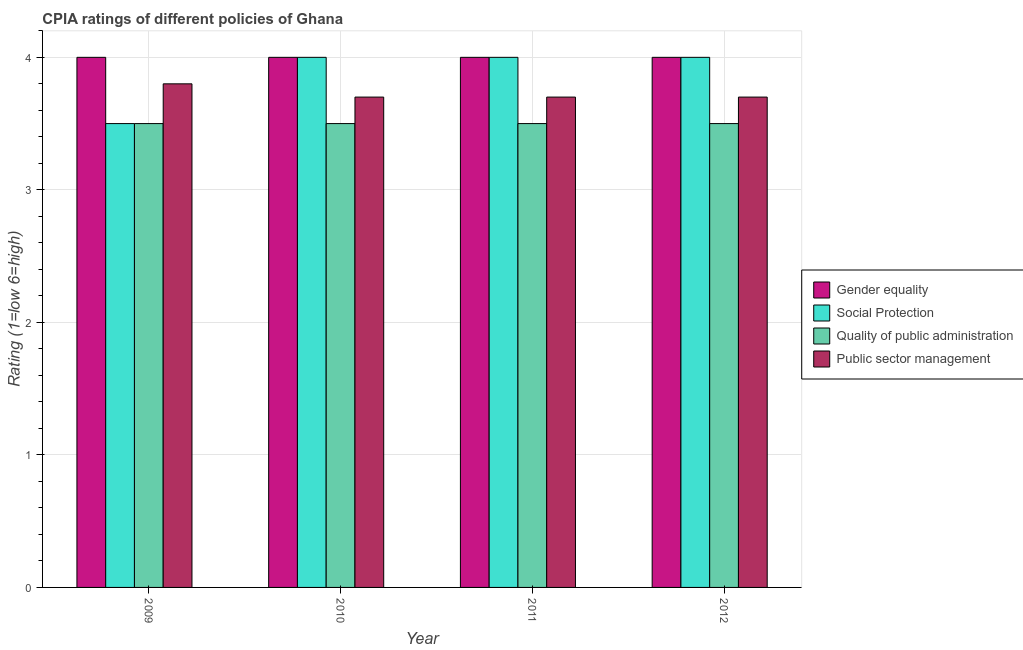How many different coloured bars are there?
Offer a very short reply. 4. How many groups of bars are there?
Give a very brief answer. 4. Are the number of bars on each tick of the X-axis equal?
Offer a very short reply. Yes. How many bars are there on the 2nd tick from the left?
Offer a very short reply. 4. What is the label of the 1st group of bars from the left?
Provide a short and direct response. 2009. Across all years, what is the maximum cpia rating of quality of public administration?
Offer a very short reply. 3.5. Across all years, what is the minimum cpia rating of quality of public administration?
Offer a terse response. 3.5. In which year was the cpia rating of gender equality maximum?
Your response must be concise. 2009. In which year was the cpia rating of gender equality minimum?
Offer a very short reply. 2009. What is the total cpia rating of public sector management in the graph?
Ensure brevity in your answer.  14.9. What is the difference between the cpia rating of gender equality in 2012 and the cpia rating of social protection in 2009?
Make the answer very short. 0. What is the average cpia rating of social protection per year?
Offer a terse response. 3.88. What is the ratio of the cpia rating of public sector management in 2010 to that in 2012?
Your response must be concise. 1. Is the cpia rating of public sector management in 2009 less than that in 2012?
Your response must be concise. No. What is the difference between the highest and the second highest cpia rating of social protection?
Provide a succinct answer. 0. Is the sum of the cpia rating of quality of public administration in 2011 and 2012 greater than the maximum cpia rating of gender equality across all years?
Give a very brief answer. Yes. What does the 3rd bar from the left in 2009 represents?
Keep it short and to the point. Quality of public administration. What does the 4th bar from the right in 2010 represents?
Ensure brevity in your answer.  Gender equality. What is the difference between two consecutive major ticks on the Y-axis?
Offer a very short reply. 1. Does the graph contain any zero values?
Provide a short and direct response. No. Does the graph contain grids?
Offer a very short reply. Yes. Where does the legend appear in the graph?
Your response must be concise. Center right. How many legend labels are there?
Ensure brevity in your answer.  4. How are the legend labels stacked?
Provide a short and direct response. Vertical. What is the title of the graph?
Offer a very short reply. CPIA ratings of different policies of Ghana. What is the Rating (1=low 6=high) in Social Protection in 2009?
Make the answer very short. 3.5. What is the Rating (1=low 6=high) of Quality of public administration in 2009?
Give a very brief answer. 3.5. What is the Rating (1=low 6=high) in Social Protection in 2010?
Your answer should be compact. 4. What is the Rating (1=low 6=high) of Gender equality in 2011?
Provide a succinct answer. 4. What is the Rating (1=low 6=high) of Social Protection in 2011?
Offer a terse response. 4. What is the Rating (1=low 6=high) of Gender equality in 2012?
Your answer should be compact. 4. What is the Rating (1=low 6=high) in Social Protection in 2012?
Offer a terse response. 4. What is the Rating (1=low 6=high) of Quality of public administration in 2012?
Provide a short and direct response. 3.5. Across all years, what is the maximum Rating (1=low 6=high) of Gender equality?
Keep it short and to the point. 4. Across all years, what is the maximum Rating (1=low 6=high) in Social Protection?
Ensure brevity in your answer.  4. Across all years, what is the minimum Rating (1=low 6=high) of Social Protection?
Provide a short and direct response. 3.5. Across all years, what is the minimum Rating (1=low 6=high) in Public sector management?
Keep it short and to the point. 3.7. What is the total Rating (1=low 6=high) of Gender equality in the graph?
Give a very brief answer. 16. What is the total Rating (1=low 6=high) in Social Protection in the graph?
Your answer should be compact. 15.5. What is the total Rating (1=low 6=high) in Quality of public administration in the graph?
Offer a very short reply. 14. What is the difference between the Rating (1=low 6=high) in Social Protection in 2009 and that in 2010?
Your answer should be compact. -0.5. What is the difference between the Rating (1=low 6=high) in Quality of public administration in 2009 and that in 2010?
Keep it short and to the point. 0. What is the difference between the Rating (1=low 6=high) of Gender equality in 2009 and that in 2011?
Your answer should be compact. 0. What is the difference between the Rating (1=low 6=high) in Quality of public administration in 2009 and that in 2011?
Make the answer very short. 0. What is the difference between the Rating (1=low 6=high) of Public sector management in 2009 and that in 2011?
Provide a succinct answer. 0.1. What is the difference between the Rating (1=low 6=high) in Gender equality in 2009 and that in 2012?
Give a very brief answer. 0. What is the difference between the Rating (1=low 6=high) in Public sector management in 2009 and that in 2012?
Your response must be concise. 0.1. What is the difference between the Rating (1=low 6=high) of Quality of public administration in 2010 and that in 2011?
Your answer should be compact. 0. What is the difference between the Rating (1=low 6=high) in Public sector management in 2010 and that in 2011?
Give a very brief answer. 0. What is the difference between the Rating (1=low 6=high) in Gender equality in 2010 and that in 2012?
Ensure brevity in your answer.  0. What is the difference between the Rating (1=low 6=high) of Social Protection in 2010 and that in 2012?
Your response must be concise. 0. What is the difference between the Rating (1=low 6=high) in Public sector management in 2010 and that in 2012?
Offer a very short reply. 0. What is the difference between the Rating (1=low 6=high) in Social Protection in 2011 and that in 2012?
Your answer should be very brief. 0. What is the difference between the Rating (1=low 6=high) in Quality of public administration in 2011 and that in 2012?
Keep it short and to the point. 0. What is the difference between the Rating (1=low 6=high) in Gender equality in 2009 and the Rating (1=low 6=high) in Social Protection in 2010?
Offer a very short reply. 0. What is the difference between the Rating (1=low 6=high) in Gender equality in 2009 and the Rating (1=low 6=high) in Quality of public administration in 2010?
Offer a terse response. 0.5. What is the difference between the Rating (1=low 6=high) of Social Protection in 2009 and the Rating (1=low 6=high) of Quality of public administration in 2010?
Offer a terse response. 0. What is the difference between the Rating (1=low 6=high) in Social Protection in 2009 and the Rating (1=low 6=high) in Public sector management in 2010?
Give a very brief answer. -0.2. What is the difference between the Rating (1=low 6=high) of Quality of public administration in 2009 and the Rating (1=low 6=high) of Public sector management in 2010?
Give a very brief answer. -0.2. What is the difference between the Rating (1=low 6=high) in Gender equality in 2009 and the Rating (1=low 6=high) in Public sector management in 2011?
Provide a short and direct response. 0.3. What is the difference between the Rating (1=low 6=high) in Social Protection in 2009 and the Rating (1=low 6=high) in Quality of public administration in 2011?
Your response must be concise. 0. What is the difference between the Rating (1=low 6=high) in Gender equality in 2009 and the Rating (1=low 6=high) in Quality of public administration in 2012?
Offer a terse response. 0.5. What is the difference between the Rating (1=low 6=high) in Gender equality in 2010 and the Rating (1=low 6=high) in Social Protection in 2011?
Keep it short and to the point. 0. What is the difference between the Rating (1=low 6=high) in Gender equality in 2010 and the Rating (1=low 6=high) in Quality of public administration in 2011?
Give a very brief answer. 0.5. What is the difference between the Rating (1=low 6=high) of Gender equality in 2010 and the Rating (1=low 6=high) of Public sector management in 2011?
Make the answer very short. 0.3. What is the difference between the Rating (1=low 6=high) in Social Protection in 2010 and the Rating (1=low 6=high) in Quality of public administration in 2011?
Keep it short and to the point. 0.5. What is the difference between the Rating (1=low 6=high) of Social Protection in 2010 and the Rating (1=low 6=high) of Public sector management in 2011?
Give a very brief answer. 0.3. What is the difference between the Rating (1=low 6=high) of Gender equality in 2010 and the Rating (1=low 6=high) of Social Protection in 2012?
Your response must be concise. 0. What is the difference between the Rating (1=low 6=high) of Gender equality in 2011 and the Rating (1=low 6=high) of Public sector management in 2012?
Provide a short and direct response. 0.3. What is the difference between the Rating (1=low 6=high) in Social Protection in 2011 and the Rating (1=low 6=high) in Quality of public administration in 2012?
Offer a very short reply. 0.5. What is the difference between the Rating (1=low 6=high) of Social Protection in 2011 and the Rating (1=low 6=high) of Public sector management in 2012?
Provide a succinct answer. 0.3. What is the average Rating (1=low 6=high) of Gender equality per year?
Provide a short and direct response. 4. What is the average Rating (1=low 6=high) in Social Protection per year?
Provide a succinct answer. 3.88. What is the average Rating (1=low 6=high) of Public sector management per year?
Offer a very short reply. 3.73. In the year 2009, what is the difference between the Rating (1=low 6=high) of Gender equality and Rating (1=low 6=high) of Social Protection?
Ensure brevity in your answer.  0.5. In the year 2009, what is the difference between the Rating (1=low 6=high) in Social Protection and Rating (1=low 6=high) in Quality of public administration?
Provide a short and direct response. 0. In the year 2010, what is the difference between the Rating (1=low 6=high) of Gender equality and Rating (1=low 6=high) of Social Protection?
Your answer should be compact. 0. In the year 2010, what is the difference between the Rating (1=low 6=high) in Gender equality and Rating (1=low 6=high) in Quality of public administration?
Your answer should be very brief. 0.5. In the year 2010, what is the difference between the Rating (1=low 6=high) of Gender equality and Rating (1=low 6=high) of Public sector management?
Your answer should be compact. 0.3. In the year 2010, what is the difference between the Rating (1=low 6=high) of Social Protection and Rating (1=low 6=high) of Public sector management?
Give a very brief answer. 0.3. In the year 2010, what is the difference between the Rating (1=low 6=high) of Quality of public administration and Rating (1=low 6=high) of Public sector management?
Offer a terse response. -0.2. In the year 2011, what is the difference between the Rating (1=low 6=high) in Gender equality and Rating (1=low 6=high) in Social Protection?
Provide a short and direct response. 0. In the year 2011, what is the difference between the Rating (1=low 6=high) in Social Protection and Rating (1=low 6=high) in Public sector management?
Ensure brevity in your answer.  0.3. In the year 2011, what is the difference between the Rating (1=low 6=high) of Quality of public administration and Rating (1=low 6=high) of Public sector management?
Your answer should be compact. -0.2. In the year 2012, what is the difference between the Rating (1=low 6=high) in Gender equality and Rating (1=low 6=high) in Quality of public administration?
Your response must be concise. 0.5. In the year 2012, what is the difference between the Rating (1=low 6=high) in Social Protection and Rating (1=low 6=high) in Quality of public administration?
Your answer should be compact. 0.5. In the year 2012, what is the difference between the Rating (1=low 6=high) in Quality of public administration and Rating (1=low 6=high) in Public sector management?
Your answer should be compact. -0.2. What is the ratio of the Rating (1=low 6=high) of Social Protection in 2009 to that in 2010?
Your response must be concise. 0.88. What is the ratio of the Rating (1=low 6=high) of Quality of public administration in 2009 to that in 2010?
Your answer should be very brief. 1. What is the ratio of the Rating (1=low 6=high) of Public sector management in 2009 to that in 2010?
Keep it short and to the point. 1.03. What is the ratio of the Rating (1=low 6=high) in Gender equality in 2009 to that in 2011?
Your response must be concise. 1. What is the ratio of the Rating (1=low 6=high) of Social Protection in 2009 to that in 2011?
Ensure brevity in your answer.  0.88. What is the ratio of the Rating (1=low 6=high) in Quality of public administration in 2009 to that in 2011?
Keep it short and to the point. 1. What is the ratio of the Rating (1=low 6=high) in Gender equality in 2009 to that in 2012?
Your answer should be very brief. 1. What is the ratio of the Rating (1=low 6=high) in Social Protection in 2010 to that in 2011?
Keep it short and to the point. 1. What is the ratio of the Rating (1=low 6=high) of Gender equality in 2010 to that in 2012?
Your answer should be very brief. 1. What is the ratio of the Rating (1=low 6=high) of Social Protection in 2010 to that in 2012?
Your answer should be compact. 1. What is the ratio of the Rating (1=low 6=high) in Gender equality in 2011 to that in 2012?
Provide a short and direct response. 1. What is the ratio of the Rating (1=low 6=high) of Quality of public administration in 2011 to that in 2012?
Offer a very short reply. 1. What is the difference between the highest and the second highest Rating (1=low 6=high) in Quality of public administration?
Provide a succinct answer. 0. What is the difference between the highest and the lowest Rating (1=low 6=high) of Gender equality?
Offer a very short reply. 0. What is the difference between the highest and the lowest Rating (1=low 6=high) of Social Protection?
Provide a short and direct response. 0.5. What is the difference between the highest and the lowest Rating (1=low 6=high) in Quality of public administration?
Your response must be concise. 0. What is the difference between the highest and the lowest Rating (1=low 6=high) in Public sector management?
Provide a short and direct response. 0.1. 